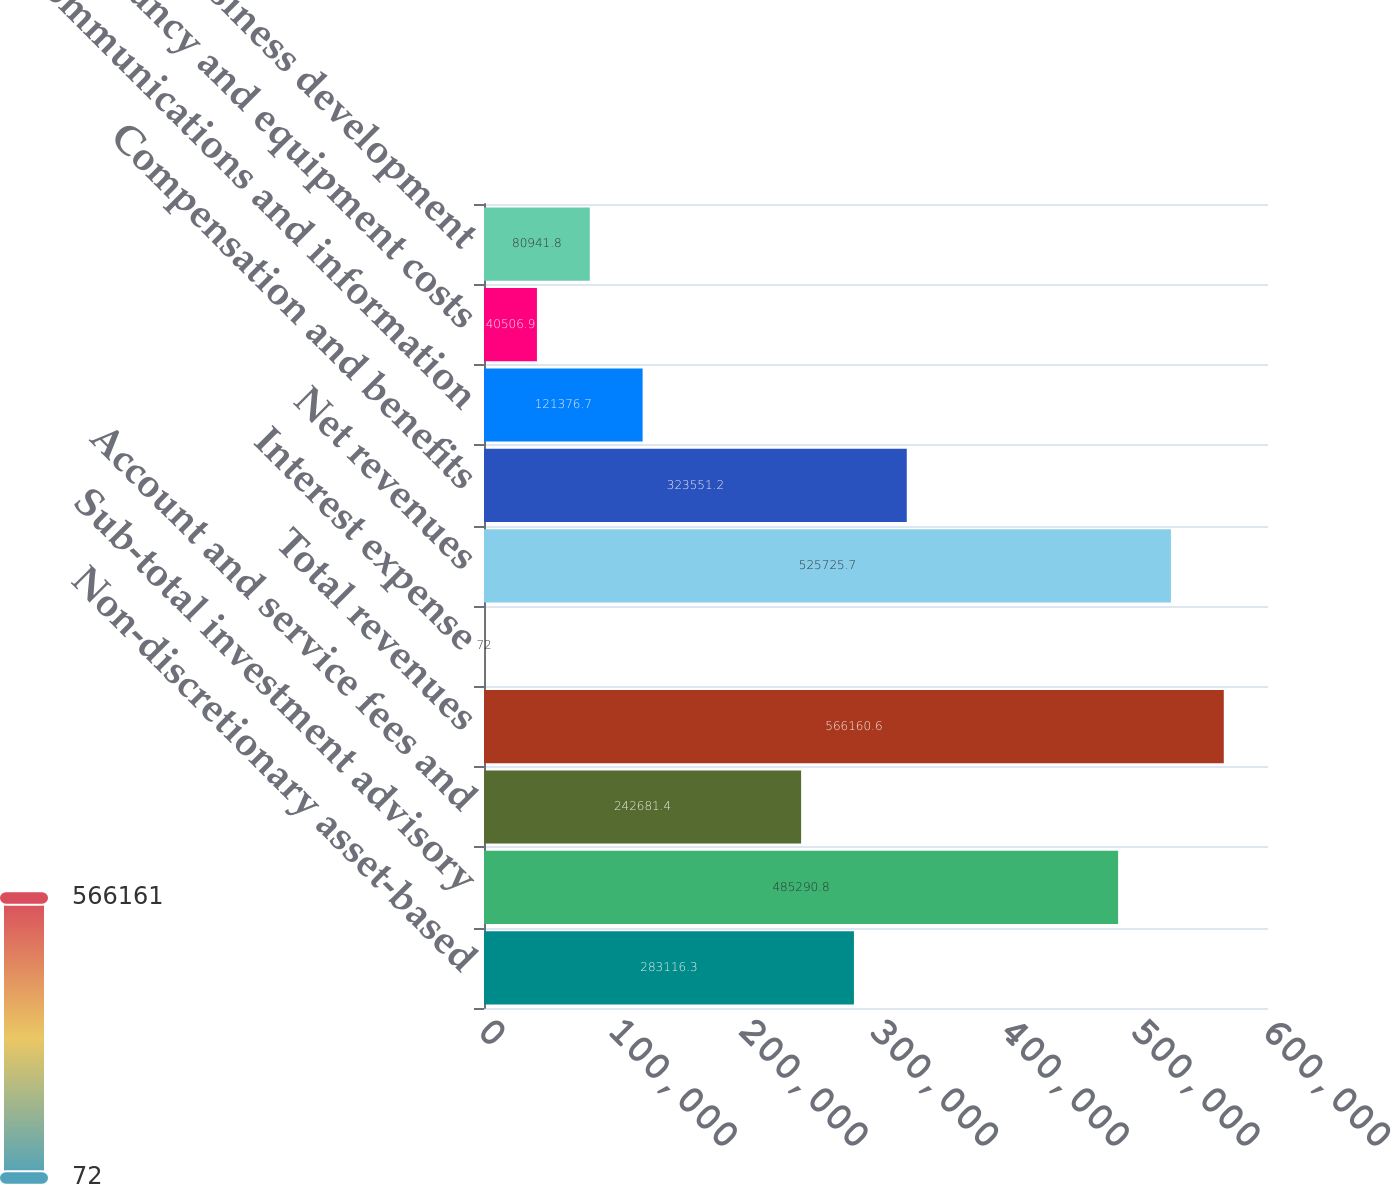Convert chart to OTSL. <chart><loc_0><loc_0><loc_500><loc_500><bar_chart><fcel>Non-discretionary asset-based<fcel>Sub-total investment advisory<fcel>Account and service fees and<fcel>Total revenues<fcel>Interest expense<fcel>Net revenues<fcel>Compensation and benefits<fcel>Communications and information<fcel>Occupancy and equipment costs<fcel>Business development<nl><fcel>283116<fcel>485291<fcel>242681<fcel>566161<fcel>72<fcel>525726<fcel>323551<fcel>121377<fcel>40506.9<fcel>80941.8<nl></chart> 